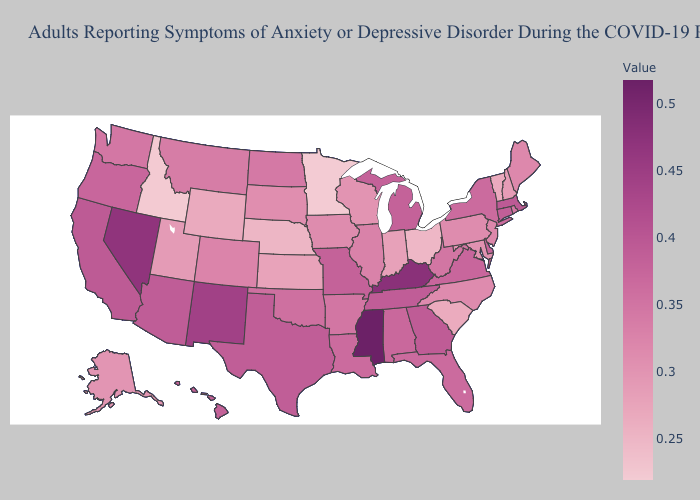Does Maryland have the highest value in the South?
Quick response, please. No. Does Massachusetts have a lower value than Ohio?
Quick response, please. No. Is the legend a continuous bar?
Concise answer only. Yes. Among the states that border Illinois , which have the lowest value?
Quick response, please. Indiana. Among the states that border Nebraska , does Iowa have the lowest value?
Short answer required. No. Does Minnesota have the lowest value in the USA?
Give a very brief answer. Yes. 